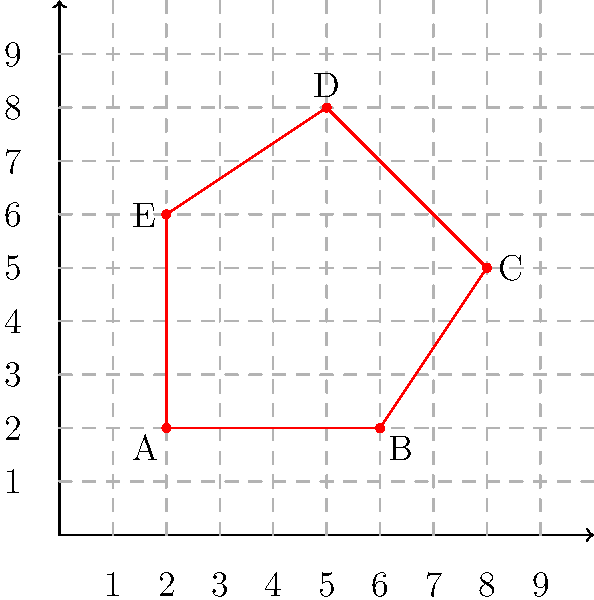As a park ranger, you've been tasked with calculating the area of a new restricted zone in the mountains to ensure visitor safety. The zone is represented by an irregular pentagon ABCDE on a coordinate grid, where each unit represents 100 meters. The coordinates of the vertices are A(2,2), B(6,2), C(8,5), D(5,8), and E(2,6). Calculate the area of this restricted zone in square kilometers. To find the area of the irregular pentagon, we can use the Shoelace formula (also known as the surveyor's formula). The steps are as follows:

1) First, let's recall the Shoelace formula for a polygon with n vertices $(x_1, y_1), (x_2, y_2), ..., (x_n, y_n)$:

   Area = $\frac{1}{2}|((x_1y_2 + x_2y_3 + ... + x_ny_1) - (y_1x_2 + y_2x_3 + ... + y_nx_1))|$

2) Substitute the given coordinates into the formula:

   Area = $\frac{1}{2}|((2 \cdot 2 + 6 \cdot 5 + 8 \cdot 8 + 5 \cdot 6 + 2 \cdot 2) - (2 \cdot 6 + 2 \cdot 8 + 5 \cdot 5 + 8 \cdot 2 + 6 \cdot 2))|$

3) Calculate each part:
   
   $\frac{1}{2}|((4 + 30 + 64 + 30 + 4) - (12 + 16 + 25 + 16 + 12))|$
   
   $\frac{1}{2}|(132 - 81)|$
   
   $\frac{1}{2}(51)$
   
   $25.5$ square units

4) Remember that each unit represents 100 meters. So, we need to multiply our result by $(100 \text{ m})^2$:

   $25.5 \cdot (100 \text{ m})^2 = 255,000 \text{ m}^2$

5) Convert to square kilometers:

   $255,000 \text{ m}^2 = 0.255 \text{ km}^2$

Therefore, the area of the restricted zone is 0.255 square kilometers.
Answer: 0.255 km² 